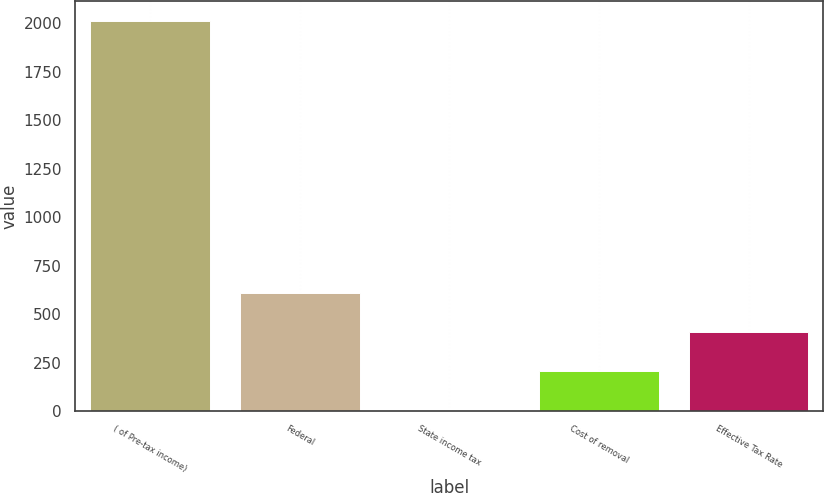Convert chart to OTSL. <chart><loc_0><loc_0><loc_500><loc_500><bar_chart><fcel>( of Pre-tax income)<fcel>Federal<fcel>State income tax<fcel>Cost of removal<fcel>Effective Tax Rate<nl><fcel>2013<fcel>607.4<fcel>5<fcel>205.8<fcel>406.6<nl></chart> 